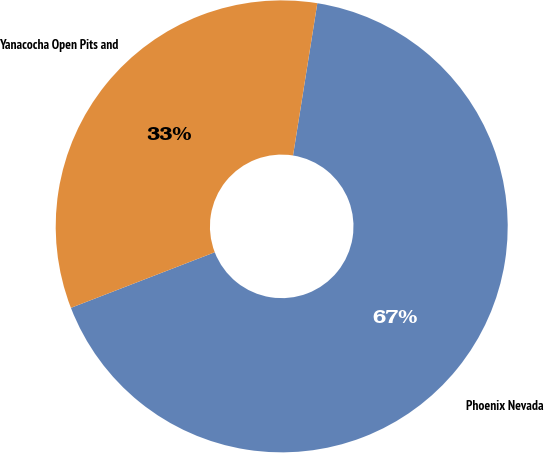<chart> <loc_0><loc_0><loc_500><loc_500><pie_chart><fcel>Phoenix Nevada<fcel>Yanacocha Open Pits and<nl><fcel>66.61%<fcel>33.39%<nl></chart> 